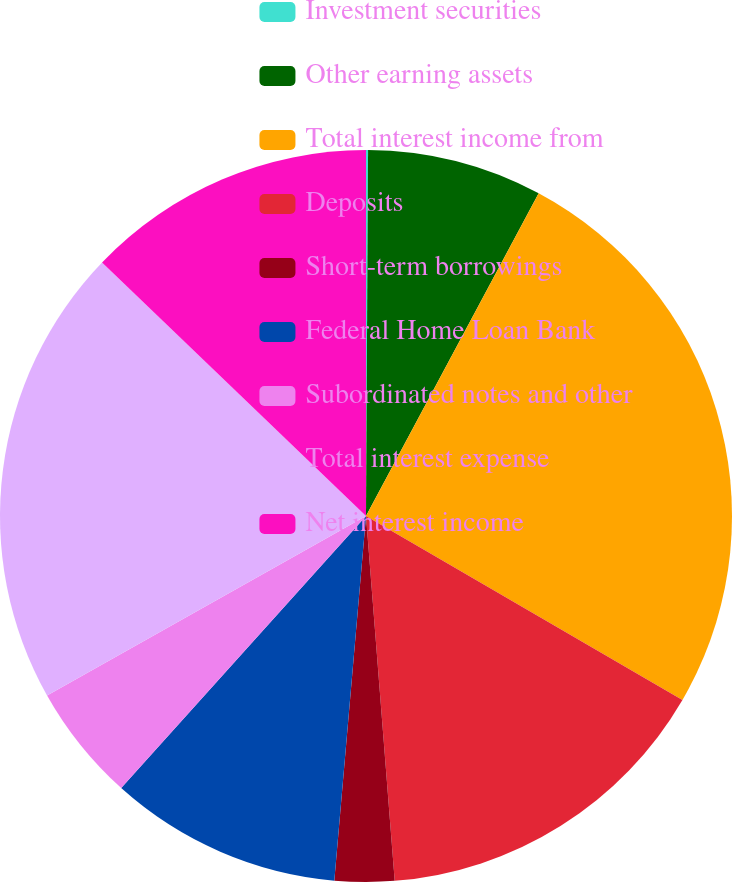Convert chart to OTSL. <chart><loc_0><loc_0><loc_500><loc_500><pie_chart><fcel>Investment securities<fcel>Other earning assets<fcel>Total interest income from<fcel>Deposits<fcel>Short-term borrowings<fcel>Federal Home Loan Bank<fcel>Subordinated notes and other<fcel>Total interest expense<fcel>Net interest income<nl><fcel>0.09%<fcel>7.73%<fcel>25.56%<fcel>15.37%<fcel>2.63%<fcel>10.28%<fcel>5.18%<fcel>20.34%<fcel>12.82%<nl></chart> 